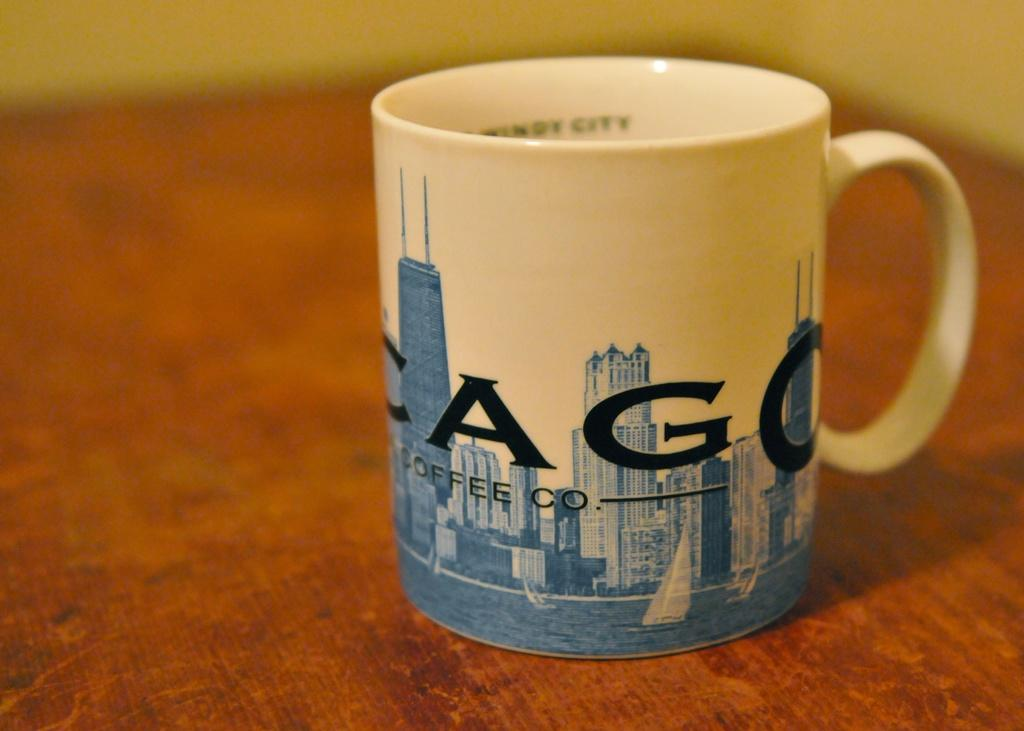<image>
Provide a brief description of the given image. A mug on a table that says Cago coffee co. 